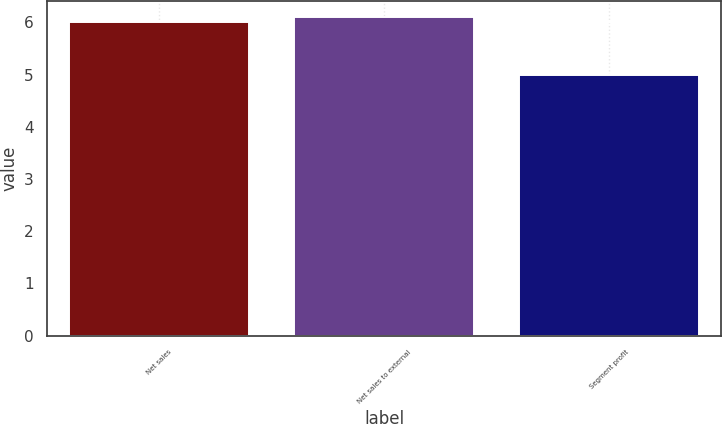Convert chart to OTSL. <chart><loc_0><loc_0><loc_500><loc_500><bar_chart><fcel>Net sales<fcel>Net sales to external<fcel>Segment profit<nl><fcel>6<fcel>6.1<fcel>5<nl></chart> 